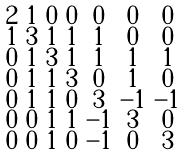<formula> <loc_0><loc_0><loc_500><loc_500>\begin{smallmatrix} 2 & 1 & 0 & 0 & 0 & 0 & 0 \\ 1 & 3 & 1 & 1 & 1 & 0 & 0 \\ 0 & 1 & 3 & 1 & 1 & 1 & 1 \\ 0 & 1 & 1 & 3 & 0 & 1 & 0 \\ 0 & 1 & 1 & 0 & 3 & - 1 & - 1 \\ 0 & 0 & 1 & 1 & - 1 & 3 & 0 \\ 0 & 0 & 1 & 0 & - 1 & 0 & 3 \end{smallmatrix}</formula> 